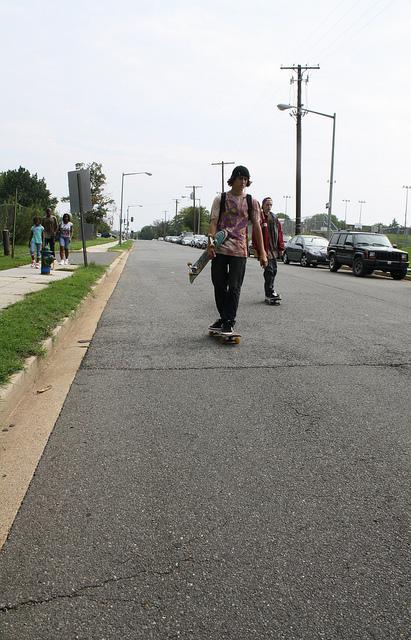Is the road smooth enough for skateboarding?
Concise answer only. Yes. Is this in countryside?
Be succinct. No. How many skateboards are there?
Answer briefly. 3. Which man is going faster?
Give a very brief answer. One in front. What are the people riding?
Short answer required. Skateboards. Is the man balanced?
Write a very short answer. Yes. Is this a one way street?
Keep it brief. No. Are they cops?
Give a very brief answer. No. What does the man have on his head?
Write a very short answer. Hat. What is the object he is skating boarding on?
Quick response, please. Skateboard. What color is the man shirt?
Give a very brief answer. Pink. What are they holding?
Be succinct. Skateboard. 